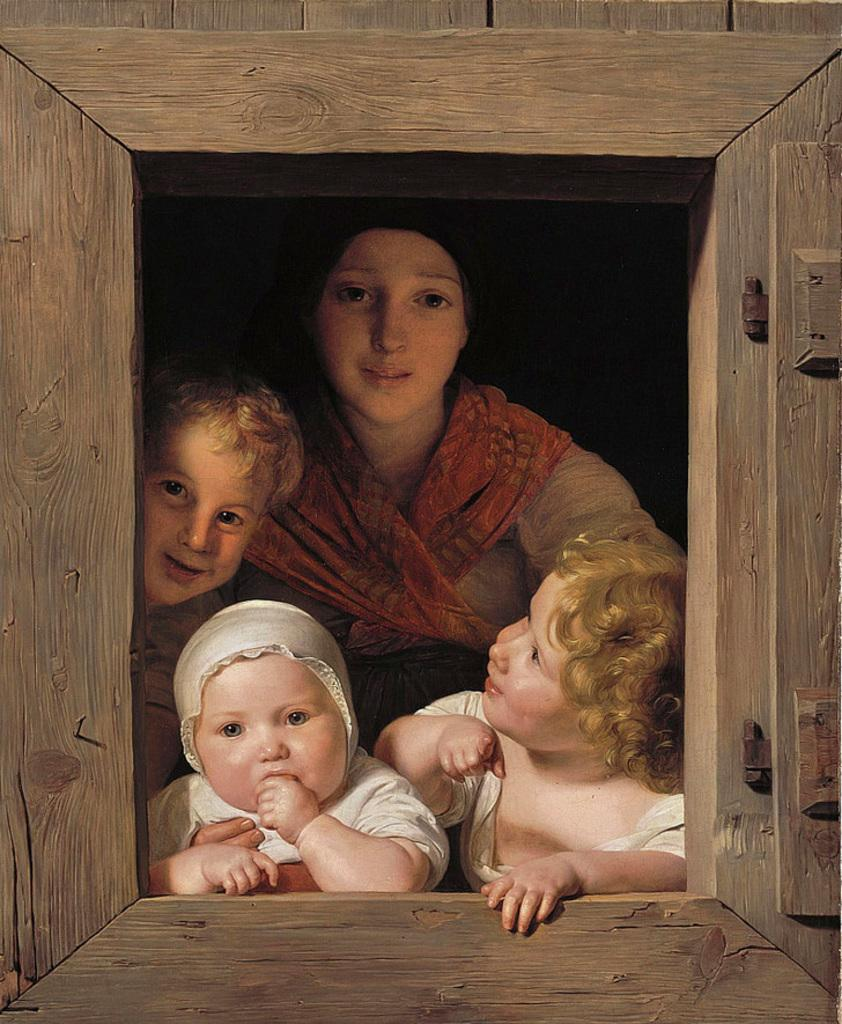What is the main subject of the image? There is a painting in the image. What is depicted in the painting? The painting contains a wooden window. How many kids are in the wooden window? There are three kids in the wooden window. Is there anyone else in the wooden window besides the kids? Yes, there is a woman in the wooden window. How many uncles can be seen walking on the road in the image? There are no uncles or roads present in the image; it features a painting with a wooden window containing three kids and a woman. 